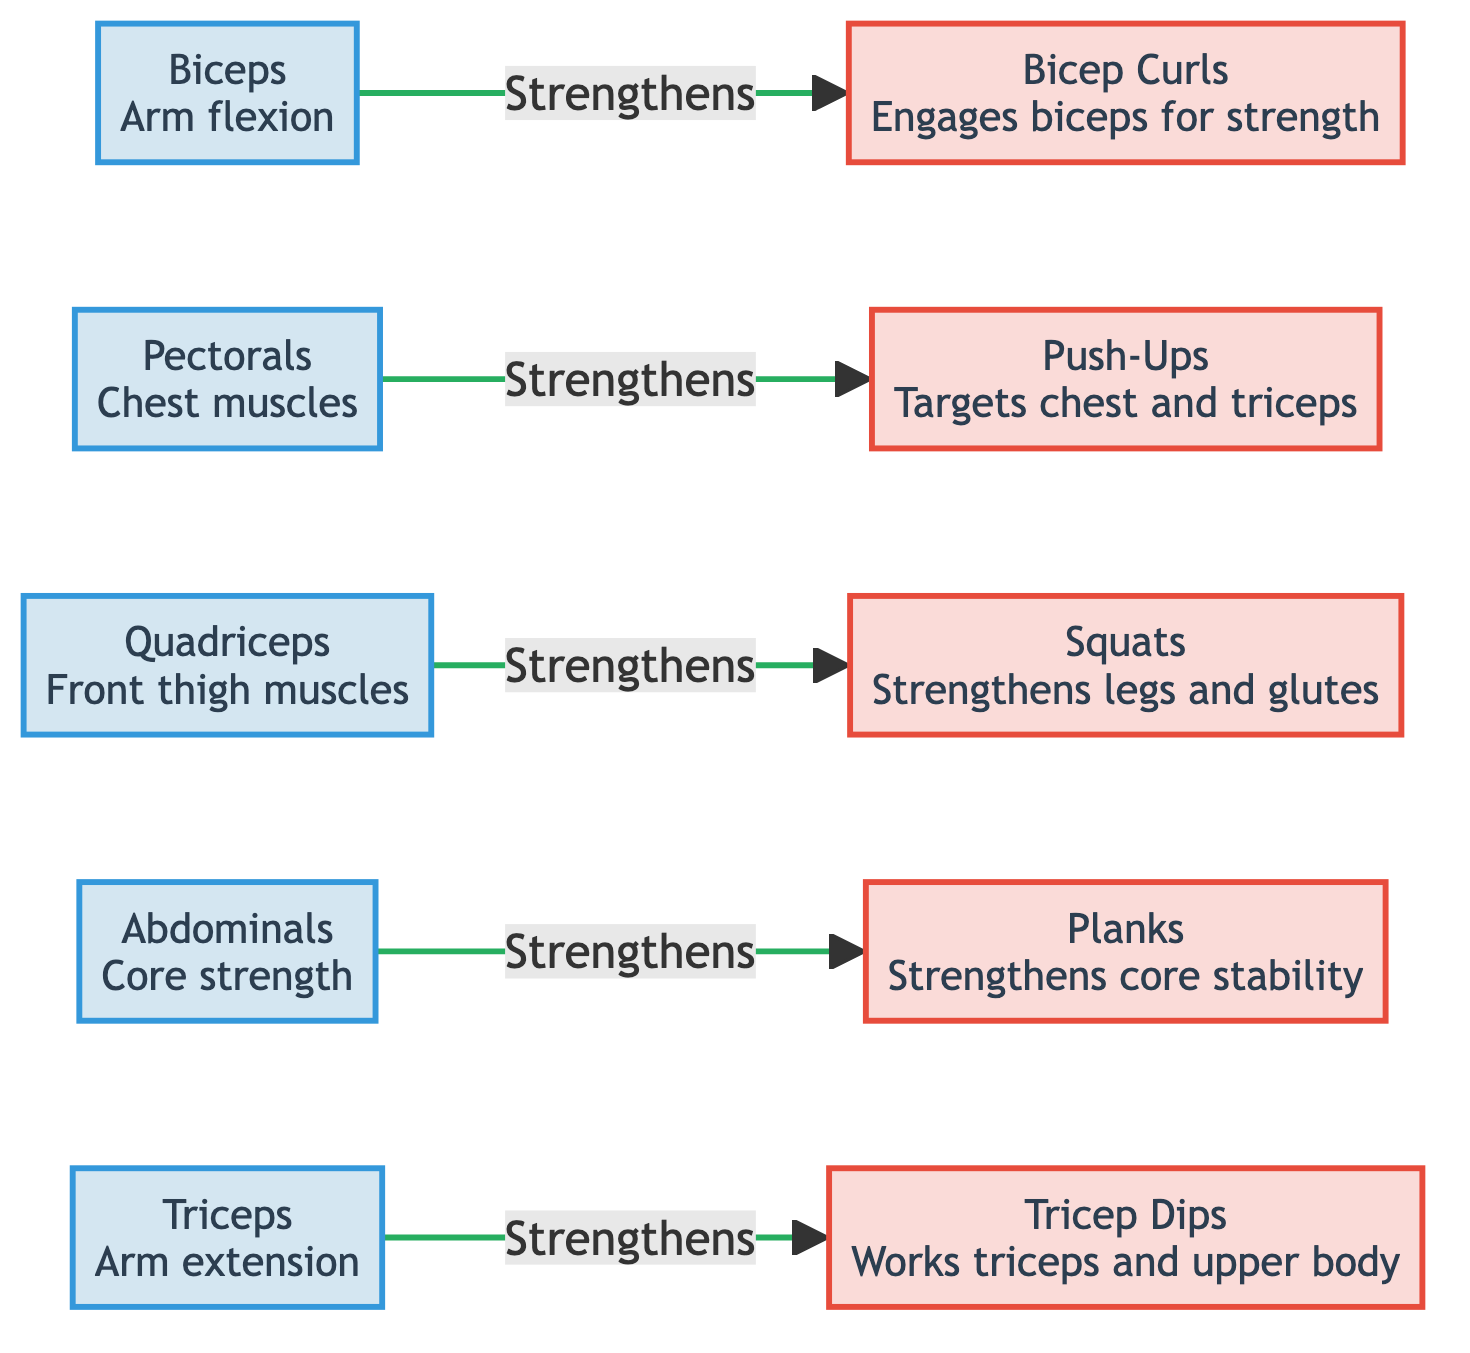What muscle group is engaged by Bicep Curls? The diagram shows that Bicep Curls engage the Biceps muscle group, as indicated by the connection from the Biceps node to the Bicep Curls exercise node.
Answer: Biceps How many strength exercises are listed in the diagram? There are five exercises depicted in the diagram: Bicep Curls, Push-Ups, Squats, Planks, and Tricep Dips. Counting these gives a total of five exercises.
Answer: 5 Which exercise strengthens the Pectorals? The diagram explicitly shows that Push-Ups are the exercise that strengthens the Pectorals, as indicated by the connection from the Pectorals node to the Push-Ups exercise node.
Answer: Push-Ups What is the function of the Abdominals in the context of this diagram? The diagram indicates that the Abdominals provide core strength. This serves as their specific function related to strength and conditioning exercises depicted.
Answer: Core strength What do Squats primarily strengthen? The diagram indicates that Squats primarily strengthen the Quadriceps and glutes, as shown by the connection from the Quadriceps node to the Squats exercise node.
Answer: Legs and glutes Which exercise works the Triceps? According to the diagram, Tricep Dips is the exercise that works the Triceps muscle group, as evidenced by the direct connection from the Triceps node to the Tricep Dips exercise node.
Answer: Tricep Dips What type of linking style is used between muscle groups and exercises? The diagram uses a solid line style with a specific stroke color to indicate the strengthening connections between muscle groups and their respective exercises. This can be deduced from the description of the link style in the code.
Answer: Solid line How many muscle groups are mentioned in the diagram? The diagram lists five muscle groups: Biceps, Pectorals, Quadriceps, Abdominals, and Triceps. Counting these gives a total of five distinct muscle groups.
Answer: 5 